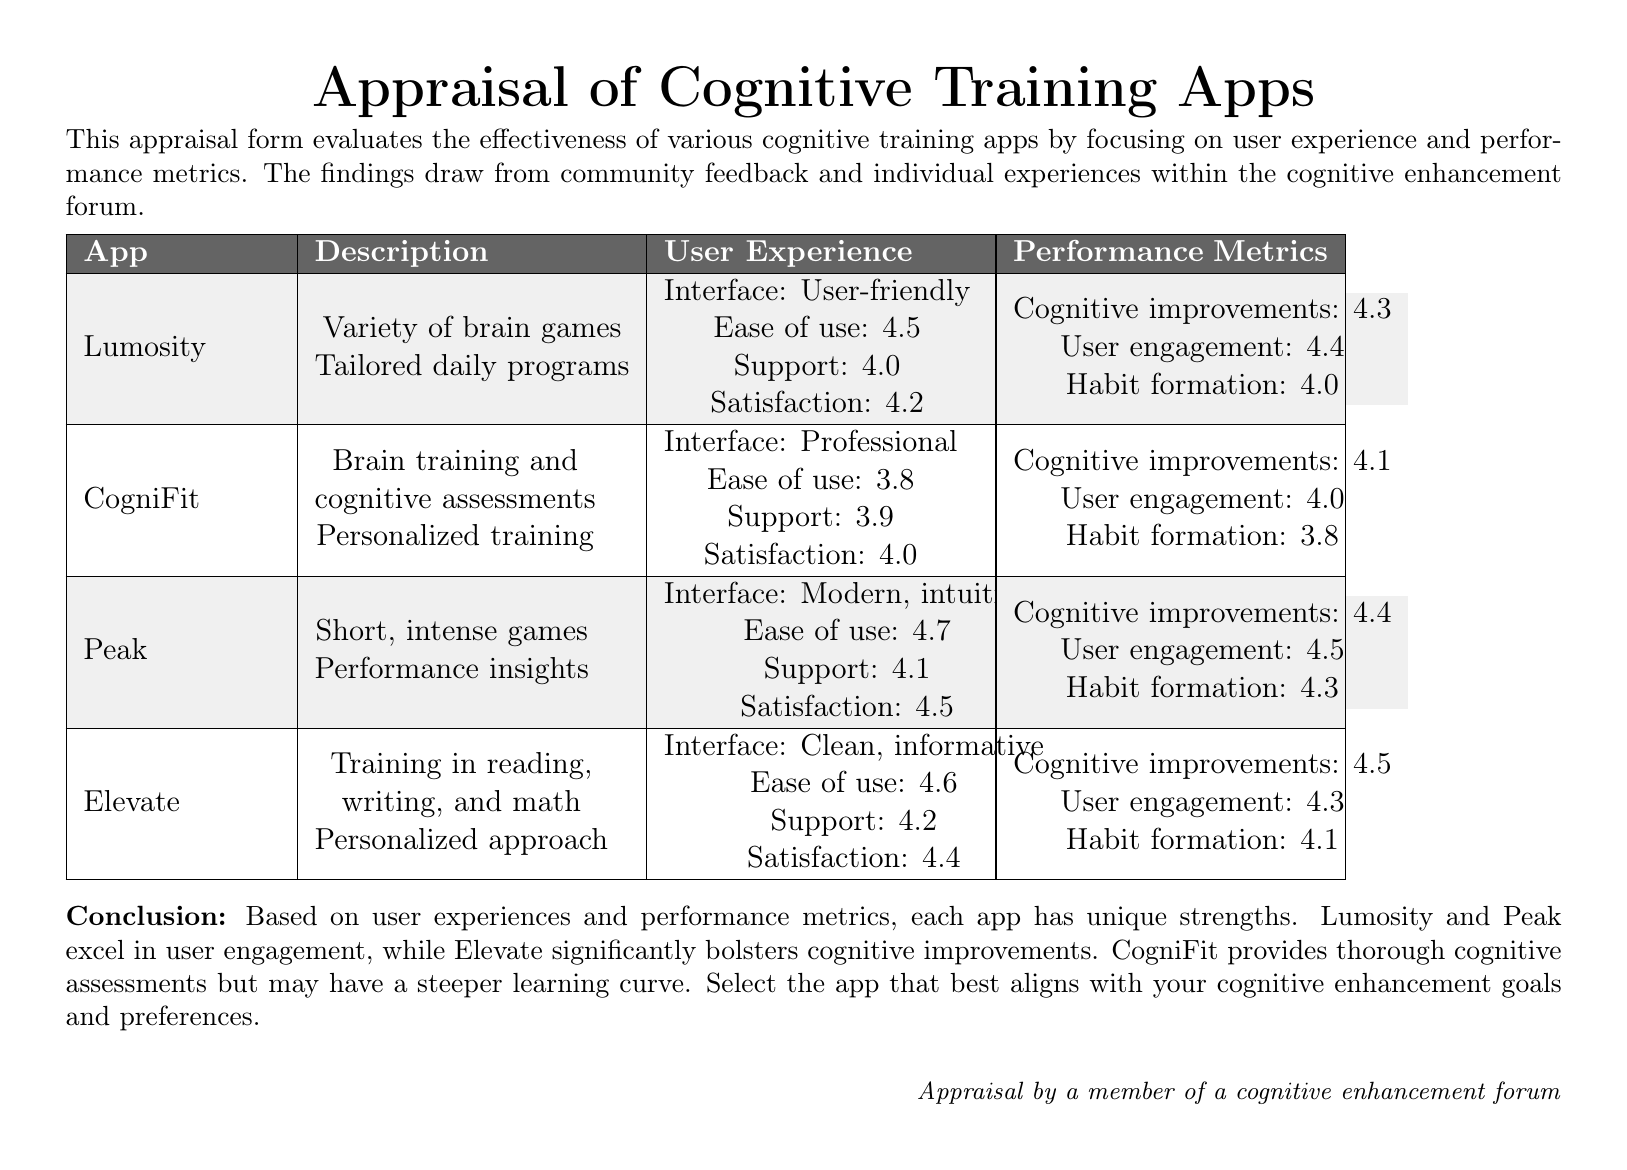What is the user satisfaction rating for Lumosity? The user satisfaction rating for Lumosity is directly stated in the document.
Answer: 4.2 What is the primary feature of CogniFit? The primary feature of CogniFit is mentioned as brain training and cognitive assessments.
Answer: Brain training and cognitive assessments Which app has the highest ease of use rating? The ease of use ratings for all apps are compared, highlighting the app with the highest rating.
Answer: Peak What cognitive improvement rating does Elevate receive? The cognitive improvement rating for Elevate is specified in the performance metrics section.
Answer: 4.5 Which app is noted for having a steeper learning curve? The document discusses CogniFit's learning curve compared to other apps.
Answer: CogniFit How does Peak's user engagement rating compare to Lumosity's? The document provides user engagement ratings for both apps for comparison.
Answer: Peak: 4.5, Lumosity: 4.4 What color is used for the header row in the table? The document specifies the colors used for different sections, including the header.
Answer: Dark gray What is the purpose of the appraisal form? The document explicitly states the purpose of the appraisal form.
Answer: To evaluate the effectiveness of various cognitive training apps Which app provides personalized training programs? The document indicates which apps offer personalized training in their descriptions.
Answer: CogniFit What conclusion is drawn about Elevate's strengths? The conclusion section specifies the strengths of Elevate based on user experiences.
Answer: Bolsters cognitive improvements 